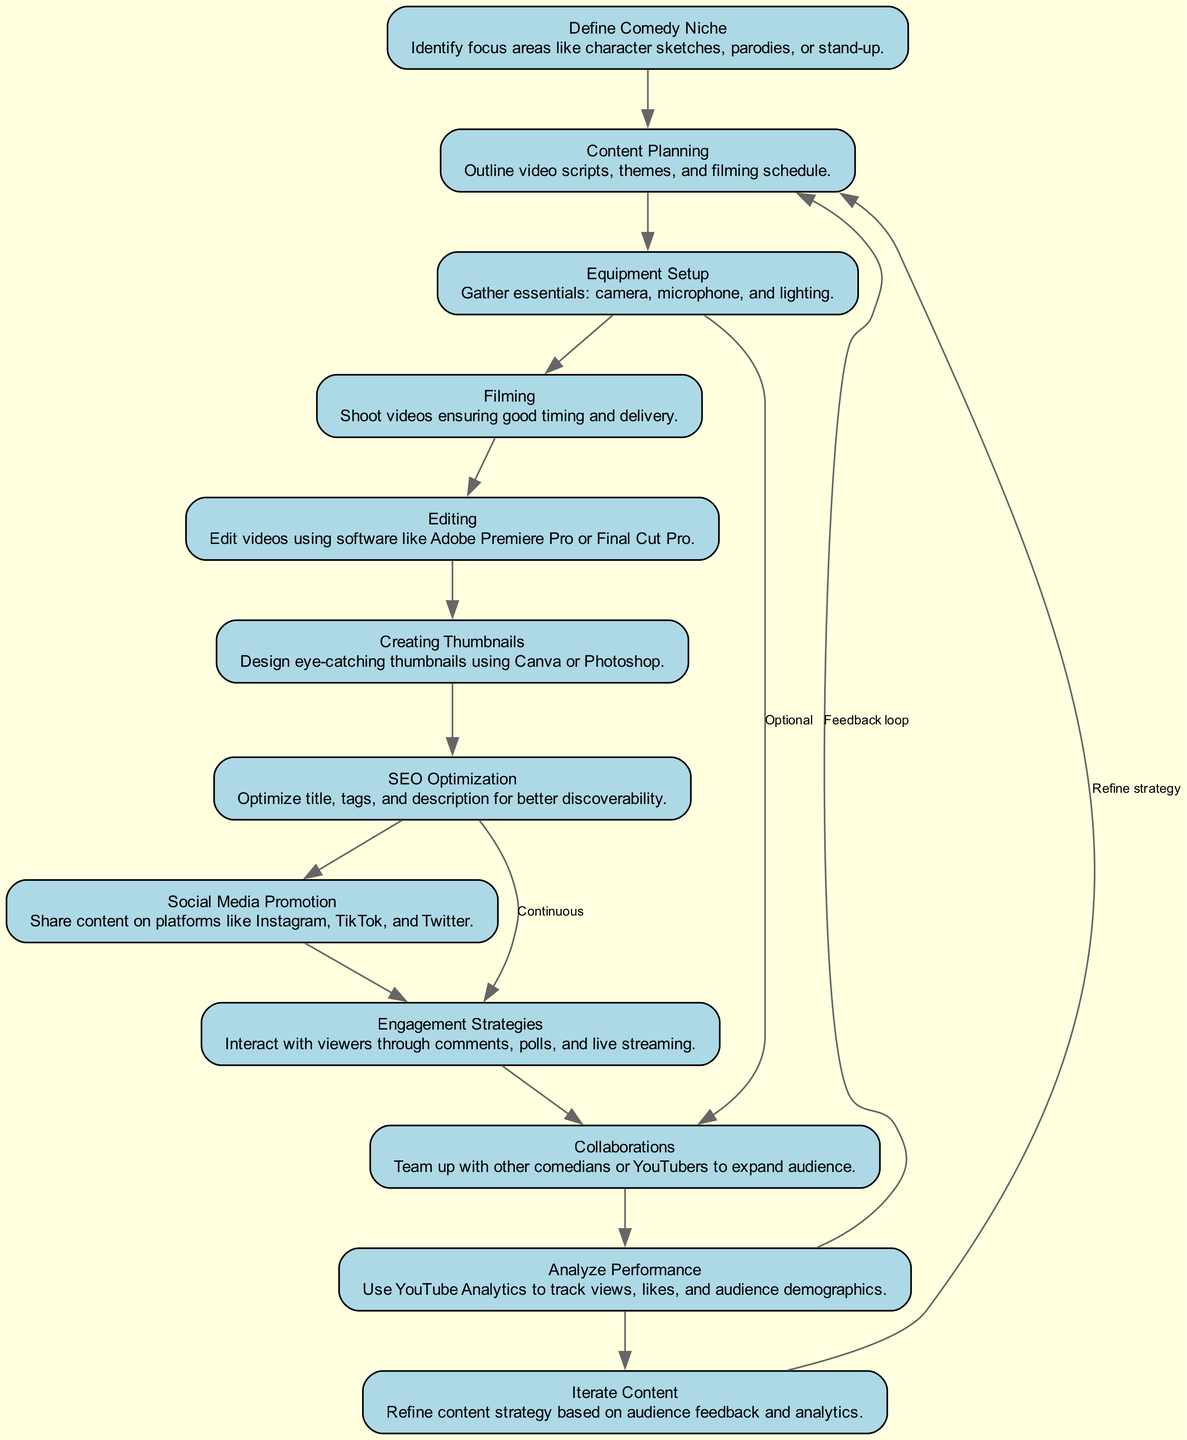What is the first step in starting a YouTube comedy channel? The first step is to "Define Comedy Niche," where you identify your focus areas such as character sketches or parodies.
Answer: Define Comedy Niche How many total steps are outlined in the flow chart? There are a total of 12 steps, as indicated by the number of nodes in the diagram.
Answer: 12 Which step comes after "Content Planning"? The step that follows "Content Planning" is "Equipment Setup." This is directly connected as per the flow of the diagram.
Answer: Equipment Setup What is an optional step in the flow chart? The optional step mentioned is "Collaborations," which has a distinct edge from "Equipment Setup."
Answer: Collaborations What relationship exists between "SEO Optimization" and "Engagement Strategies"? The relationship is continuous, indicating that SEO leads to ongoing audience engagement tactics. This is shown by the specific edge labeled 'Continuous' between these two steps.
Answer: Continuous What is the last step in the process shown in the flow chart? The final step outlined in the flow chart is "Iterate Content," which comes at the end of the sequence.
Answer: Iterate Content Which step involves analyzing video performance? The step that involves analyzing video performance is "Analyze Performance," where YouTube Analytics is used to track metrics.
Answer: Analyze Performance How does the flow from "Analyze Performance" connect back to the diagram? The flow connects back to "Content Planning" as it indicates the feedback loop for refining future video content strategies based on analytics.
Answer: Feedback loop What tool is suggested for video editing in the content creation process? The suggested tool for video editing is "Adobe Premiere Pro" or "Final Cut Pro," as stated in the description of the "Editing" step.
Answer: Adobe Premiere Pro or Final Cut Pro What type of strategy is used to interact with viewers? The strategy for interaction with viewers is termed "Engagement Strategies," which includes tools like comments and polls.
Answer: Engagement Strategies 